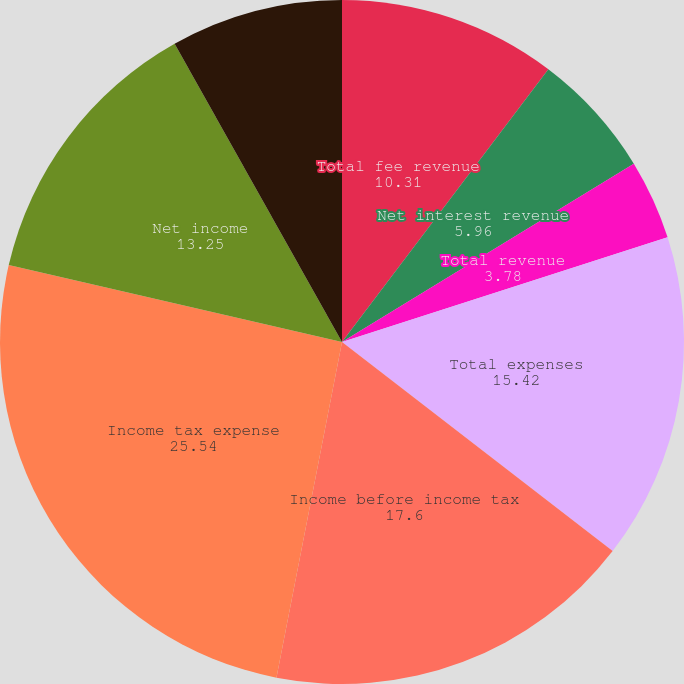Convert chart. <chart><loc_0><loc_0><loc_500><loc_500><pie_chart><fcel>Total fee revenue<fcel>Net interest revenue<fcel>Total revenue<fcel>Total expenses<fcel>Income before income tax<fcel>Income tax expense<fcel>Net income<fcel>Net income before<nl><fcel>10.31%<fcel>5.96%<fcel>3.78%<fcel>15.42%<fcel>17.6%<fcel>25.54%<fcel>13.25%<fcel>8.14%<nl></chart> 